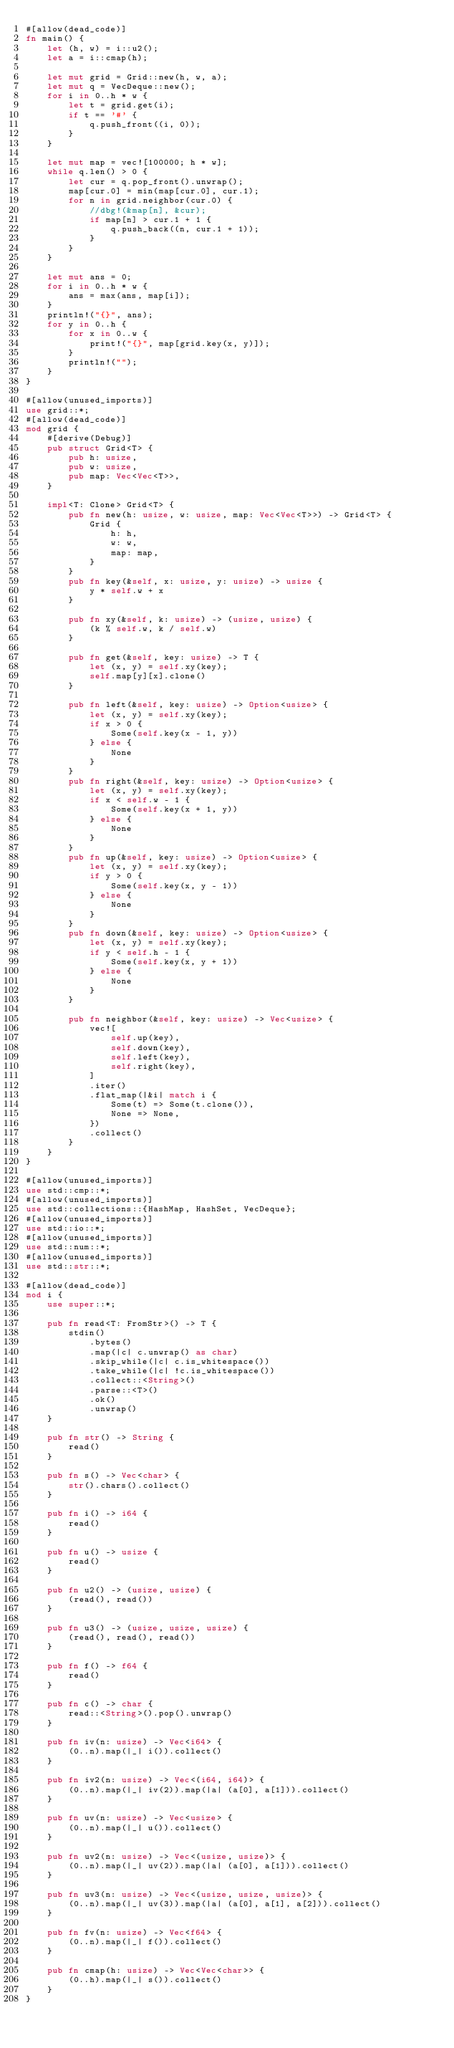Convert code to text. <code><loc_0><loc_0><loc_500><loc_500><_Rust_>#[allow(dead_code)]
fn main() {
    let (h, w) = i::u2();
    let a = i::cmap(h);

    let mut grid = Grid::new(h, w, a);
    let mut q = VecDeque::new();
    for i in 0..h * w {
        let t = grid.get(i);
        if t == '#' {
            q.push_front((i, 0));
        }
    }

    let mut map = vec![100000; h * w];
    while q.len() > 0 {
        let cur = q.pop_front().unwrap();
        map[cur.0] = min(map[cur.0], cur.1);
        for n in grid.neighbor(cur.0) {
            //dbg!(&map[n], &cur);
            if map[n] > cur.1 + 1 {
                q.push_back((n, cur.1 + 1));
            }
        }
    }

    let mut ans = 0;
    for i in 0..h * w {
        ans = max(ans, map[i]);
    }
    println!("{}", ans);
    for y in 0..h {
        for x in 0..w {
            print!("{}", map[grid.key(x, y)]);
        }
        println!("");
    }
}

#[allow(unused_imports)]
use grid::*;
#[allow(dead_code)]
mod grid {
    #[derive(Debug)]
    pub struct Grid<T> {
        pub h: usize,
        pub w: usize,
        pub map: Vec<Vec<T>>,
    }

    impl<T: Clone> Grid<T> {
        pub fn new(h: usize, w: usize, map: Vec<Vec<T>>) -> Grid<T> {
            Grid {
                h: h,
                w: w,
                map: map,
            }
        }
        pub fn key(&self, x: usize, y: usize) -> usize {
            y * self.w + x
        }

        pub fn xy(&self, k: usize) -> (usize, usize) {
            (k % self.w, k / self.w)
        }

        pub fn get(&self, key: usize) -> T {
            let (x, y) = self.xy(key);
            self.map[y][x].clone()
        }

        pub fn left(&self, key: usize) -> Option<usize> {
            let (x, y) = self.xy(key);
            if x > 0 {
                Some(self.key(x - 1, y))
            } else {
                None
            }
        }
        pub fn right(&self, key: usize) -> Option<usize> {
            let (x, y) = self.xy(key);
            if x < self.w - 1 {
                Some(self.key(x + 1, y))
            } else {
                None
            }
        }
        pub fn up(&self, key: usize) -> Option<usize> {
            let (x, y) = self.xy(key);
            if y > 0 {
                Some(self.key(x, y - 1))
            } else {
                None
            }
        }
        pub fn down(&self, key: usize) -> Option<usize> {
            let (x, y) = self.xy(key);
            if y < self.h - 1 {
                Some(self.key(x, y + 1))
            } else {
                None
            }
        }

        pub fn neighbor(&self, key: usize) -> Vec<usize> {
            vec![
                self.up(key),
                self.down(key),
                self.left(key),
                self.right(key),
            ]
            .iter()
            .flat_map(|&i| match i {
                Some(t) => Some(t.clone()),
                None => None,
            })
            .collect()
        }
    }
}

#[allow(unused_imports)]
use std::cmp::*;
#[allow(unused_imports)]
use std::collections::{HashMap, HashSet, VecDeque};
#[allow(unused_imports)]
use std::io::*;
#[allow(unused_imports)]
use std::num::*;
#[allow(unused_imports)]
use std::str::*;

#[allow(dead_code)]
mod i {
    use super::*;

    pub fn read<T: FromStr>() -> T {
        stdin()
            .bytes()
            .map(|c| c.unwrap() as char)
            .skip_while(|c| c.is_whitespace())
            .take_while(|c| !c.is_whitespace())
            .collect::<String>()
            .parse::<T>()
            .ok()
            .unwrap()
    }

    pub fn str() -> String {
        read()
    }

    pub fn s() -> Vec<char> {
        str().chars().collect()
    }

    pub fn i() -> i64 {
        read()
    }

    pub fn u() -> usize {
        read()
    }

    pub fn u2() -> (usize, usize) {
        (read(), read())
    }

    pub fn u3() -> (usize, usize, usize) {
        (read(), read(), read())
    }

    pub fn f() -> f64 {
        read()
    }

    pub fn c() -> char {
        read::<String>().pop().unwrap()
    }

    pub fn iv(n: usize) -> Vec<i64> {
        (0..n).map(|_| i()).collect()
    }

    pub fn iv2(n: usize) -> Vec<(i64, i64)> {
        (0..n).map(|_| iv(2)).map(|a| (a[0], a[1])).collect()
    }

    pub fn uv(n: usize) -> Vec<usize> {
        (0..n).map(|_| u()).collect()
    }

    pub fn uv2(n: usize) -> Vec<(usize, usize)> {
        (0..n).map(|_| uv(2)).map(|a| (a[0], a[1])).collect()
    }

    pub fn uv3(n: usize) -> Vec<(usize, usize, usize)> {
        (0..n).map(|_| uv(3)).map(|a| (a[0], a[1], a[2])).collect()
    }

    pub fn fv(n: usize) -> Vec<f64> {
        (0..n).map(|_| f()).collect()
    }

    pub fn cmap(h: usize) -> Vec<Vec<char>> {
        (0..h).map(|_| s()).collect()
    }
}
</code> 